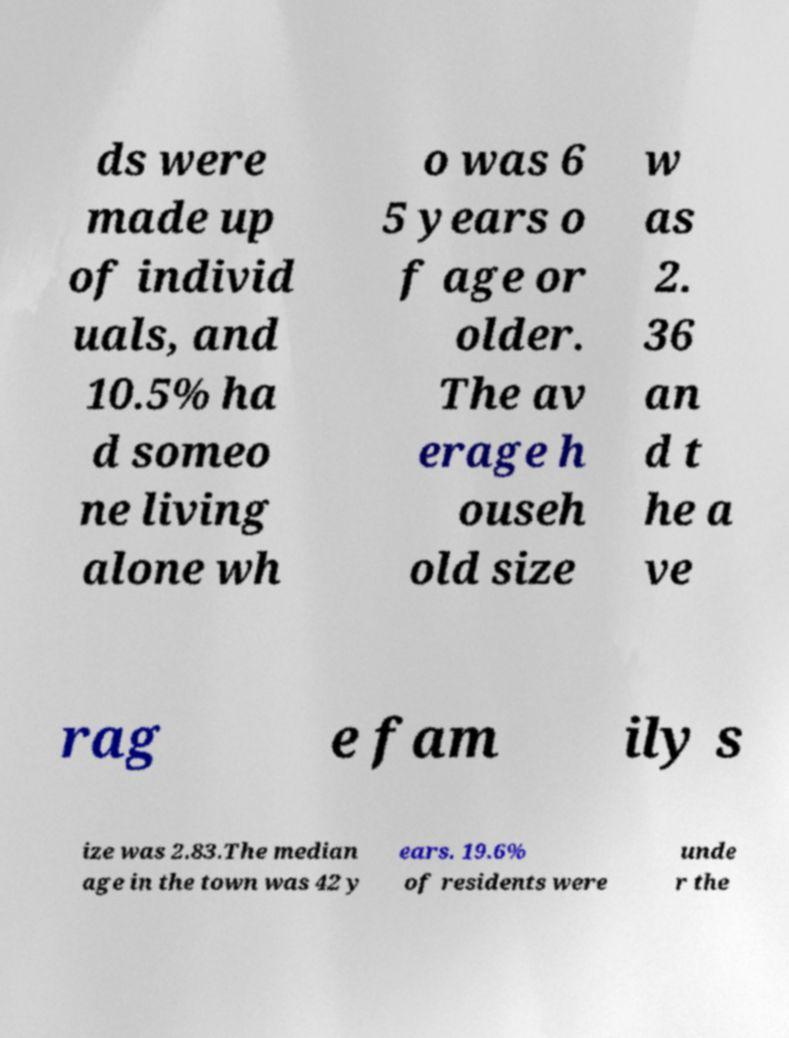Could you assist in decoding the text presented in this image and type it out clearly? ds were made up of individ uals, and 10.5% ha d someo ne living alone wh o was 6 5 years o f age or older. The av erage h ouseh old size w as 2. 36 an d t he a ve rag e fam ily s ize was 2.83.The median age in the town was 42 y ears. 19.6% of residents were unde r the 